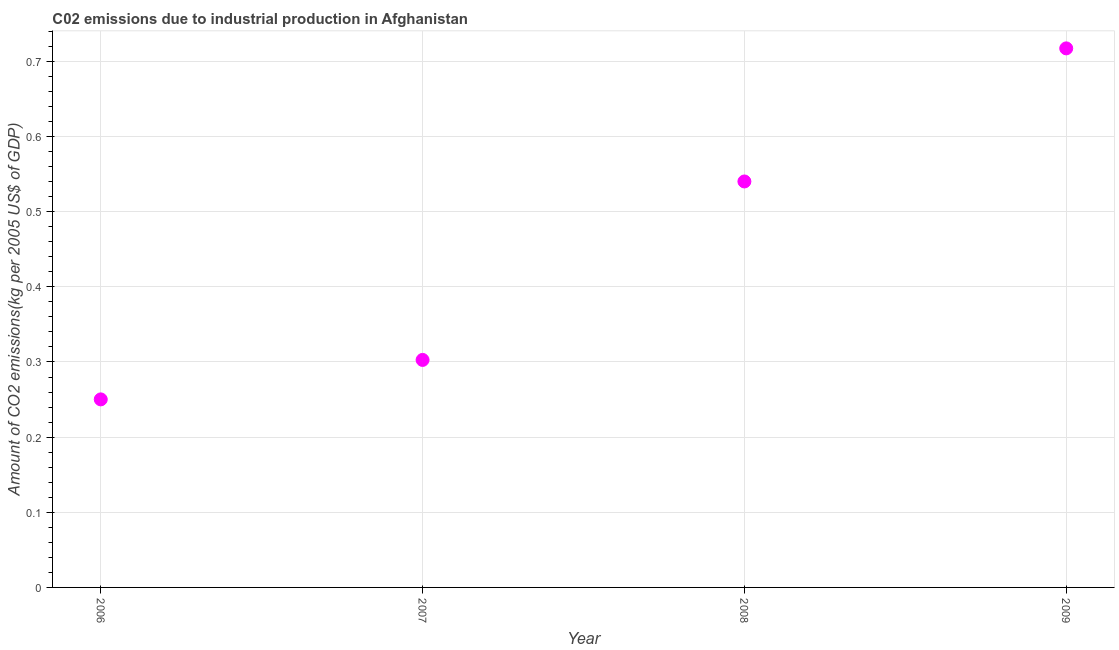What is the amount of co2 emissions in 2006?
Make the answer very short. 0.25. Across all years, what is the maximum amount of co2 emissions?
Your response must be concise. 0.72. Across all years, what is the minimum amount of co2 emissions?
Your response must be concise. 0.25. In which year was the amount of co2 emissions maximum?
Provide a succinct answer. 2009. In which year was the amount of co2 emissions minimum?
Provide a succinct answer. 2006. What is the sum of the amount of co2 emissions?
Provide a short and direct response. 1.81. What is the difference between the amount of co2 emissions in 2007 and 2008?
Keep it short and to the point. -0.24. What is the average amount of co2 emissions per year?
Make the answer very short. 0.45. What is the median amount of co2 emissions?
Keep it short and to the point. 0.42. In how many years, is the amount of co2 emissions greater than 0.30000000000000004 kg per 2005 US$ of GDP?
Give a very brief answer. 3. What is the ratio of the amount of co2 emissions in 2007 to that in 2009?
Make the answer very short. 0.42. Is the amount of co2 emissions in 2007 less than that in 2009?
Ensure brevity in your answer.  Yes. Is the difference between the amount of co2 emissions in 2006 and 2008 greater than the difference between any two years?
Keep it short and to the point. No. What is the difference between the highest and the second highest amount of co2 emissions?
Your answer should be compact. 0.18. Is the sum of the amount of co2 emissions in 2006 and 2007 greater than the maximum amount of co2 emissions across all years?
Offer a terse response. No. What is the difference between the highest and the lowest amount of co2 emissions?
Keep it short and to the point. 0.47. In how many years, is the amount of co2 emissions greater than the average amount of co2 emissions taken over all years?
Give a very brief answer. 2. How many dotlines are there?
Offer a terse response. 1. What is the difference between two consecutive major ticks on the Y-axis?
Give a very brief answer. 0.1. Are the values on the major ticks of Y-axis written in scientific E-notation?
Provide a succinct answer. No. Does the graph contain any zero values?
Keep it short and to the point. No. What is the title of the graph?
Your response must be concise. C02 emissions due to industrial production in Afghanistan. What is the label or title of the X-axis?
Your answer should be very brief. Year. What is the label or title of the Y-axis?
Ensure brevity in your answer.  Amount of CO2 emissions(kg per 2005 US$ of GDP). What is the Amount of CO2 emissions(kg per 2005 US$ of GDP) in 2006?
Ensure brevity in your answer.  0.25. What is the Amount of CO2 emissions(kg per 2005 US$ of GDP) in 2007?
Your answer should be very brief. 0.3. What is the Amount of CO2 emissions(kg per 2005 US$ of GDP) in 2008?
Provide a succinct answer. 0.54. What is the Amount of CO2 emissions(kg per 2005 US$ of GDP) in 2009?
Keep it short and to the point. 0.72. What is the difference between the Amount of CO2 emissions(kg per 2005 US$ of GDP) in 2006 and 2007?
Ensure brevity in your answer.  -0.05. What is the difference between the Amount of CO2 emissions(kg per 2005 US$ of GDP) in 2006 and 2008?
Offer a very short reply. -0.29. What is the difference between the Amount of CO2 emissions(kg per 2005 US$ of GDP) in 2006 and 2009?
Your answer should be very brief. -0.47. What is the difference between the Amount of CO2 emissions(kg per 2005 US$ of GDP) in 2007 and 2008?
Provide a short and direct response. -0.24. What is the difference between the Amount of CO2 emissions(kg per 2005 US$ of GDP) in 2007 and 2009?
Ensure brevity in your answer.  -0.41. What is the difference between the Amount of CO2 emissions(kg per 2005 US$ of GDP) in 2008 and 2009?
Give a very brief answer. -0.18. What is the ratio of the Amount of CO2 emissions(kg per 2005 US$ of GDP) in 2006 to that in 2007?
Provide a succinct answer. 0.83. What is the ratio of the Amount of CO2 emissions(kg per 2005 US$ of GDP) in 2006 to that in 2008?
Your answer should be very brief. 0.46. What is the ratio of the Amount of CO2 emissions(kg per 2005 US$ of GDP) in 2006 to that in 2009?
Keep it short and to the point. 0.35. What is the ratio of the Amount of CO2 emissions(kg per 2005 US$ of GDP) in 2007 to that in 2008?
Keep it short and to the point. 0.56. What is the ratio of the Amount of CO2 emissions(kg per 2005 US$ of GDP) in 2007 to that in 2009?
Offer a terse response. 0.42. What is the ratio of the Amount of CO2 emissions(kg per 2005 US$ of GDP) in 2008 to that in 2009?
Give a very brief answer. 0.75. 